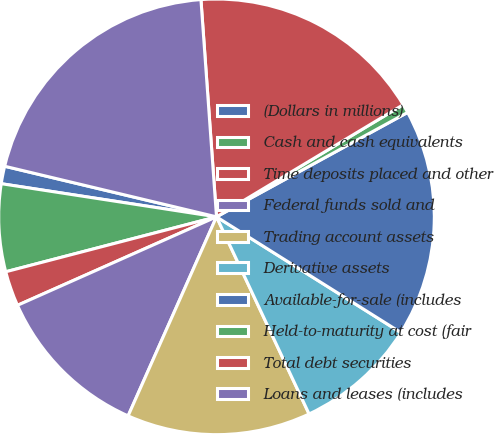Convert chart. <chart><loc_0><loc_0><loc_500><loc_500><pie_chart><fcel>(Dollars in millions)<fcel>Cash and cash equivalents<fcel>Time deposits placed and other<fcel>Federal funds sold and<fcel>Trading account assets<fcel>Derivative assets<fcel>Available-for-sale (includes<fcel>Held-to-maturity at cost (fair<fcel>Total debt securities<fcel>Loans and leases (includes<nl><fcel>1.3%<fcel>6.49%<fcel>2.6%<fcel>11.69%<fcel>13.64%<fcel>9.09%<fcel>16.88%<fcel>0.65%<fcel>17.53%<fcel>20.13%<nl></chart> 